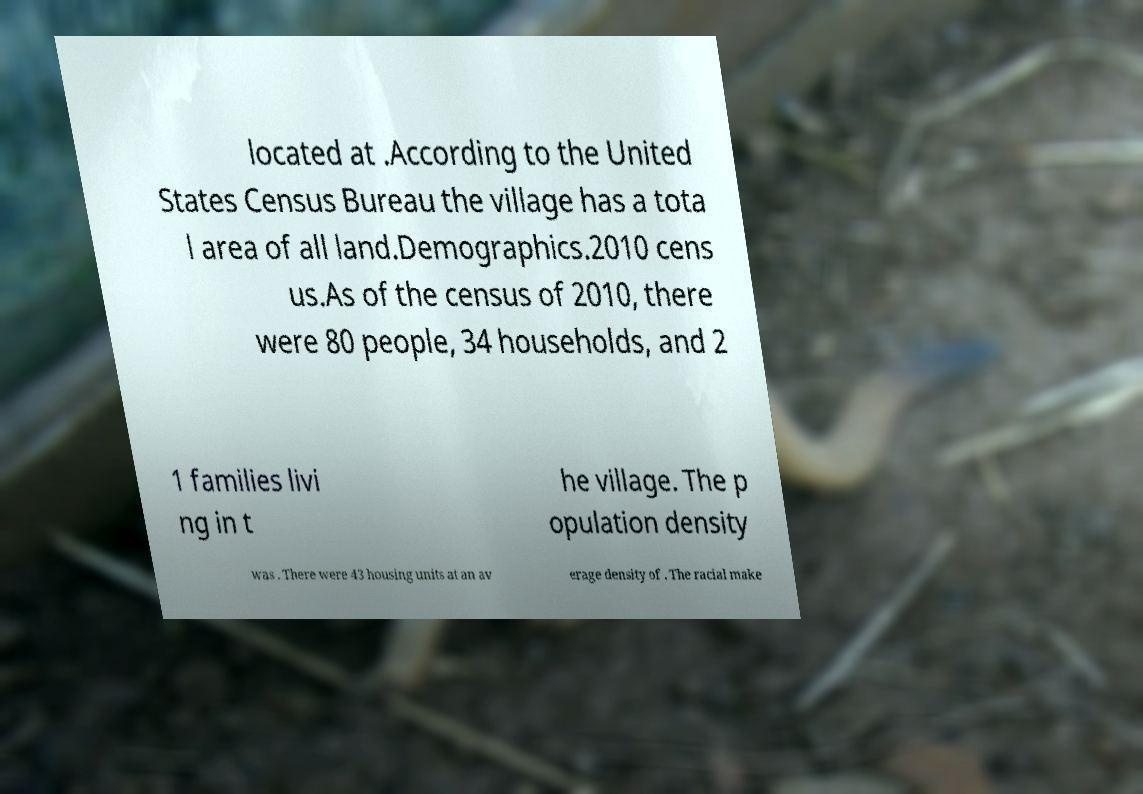For documentation purposes, I need the text within this image transcribed. Could you provide that? located at .According to the United States Census Bureau the village has a tota l area of all land.Demographics.2010 cens us.As of the census of 2010, there were 80 people, 34 households, and 2 1 families livi ng in t he village. The p opulation density was . There were 43 housing units at an av erage density of . The racial make 